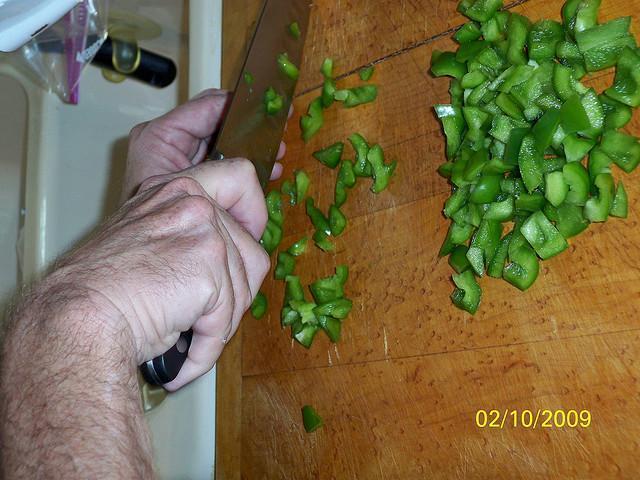How many benches are there?
Give a very brief answer. 0. 